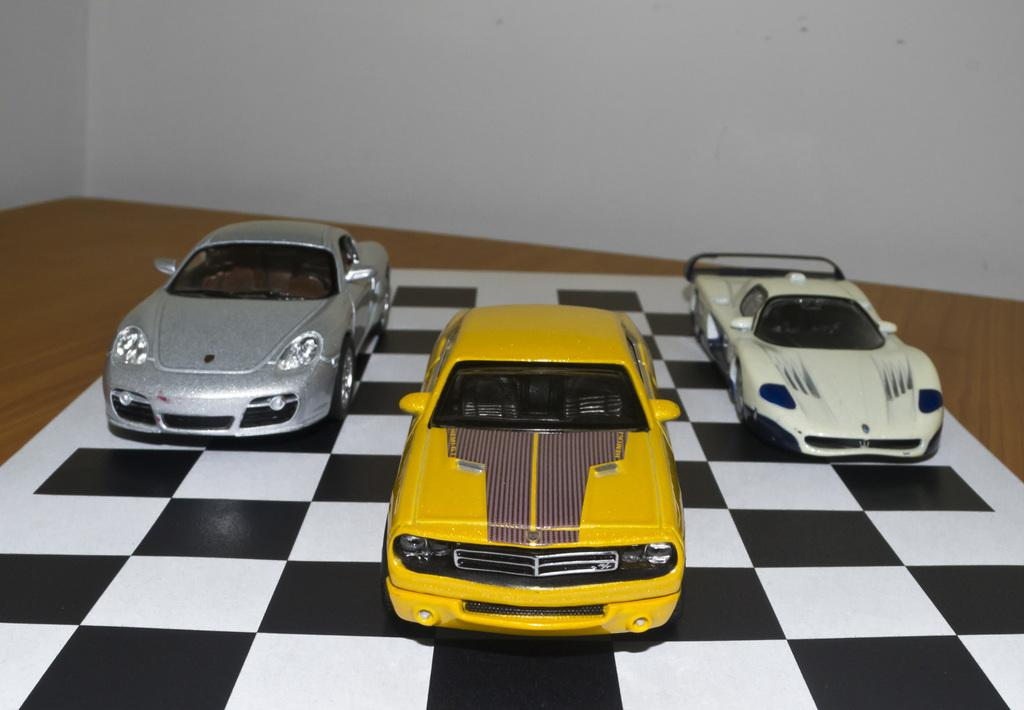What objects are in the foreground of the image? There are three toy cars in the foreground of the image. What surface are the toy cars placed on? The toy cars are on a chess board. Where is the chess board located? The chess board is on a table. What can be seen in the background of the image? There is a wall in the background of the image. How many fish are swimming in the spot on the wall in the image? There are no fish or spots visible on the wall in the image. 